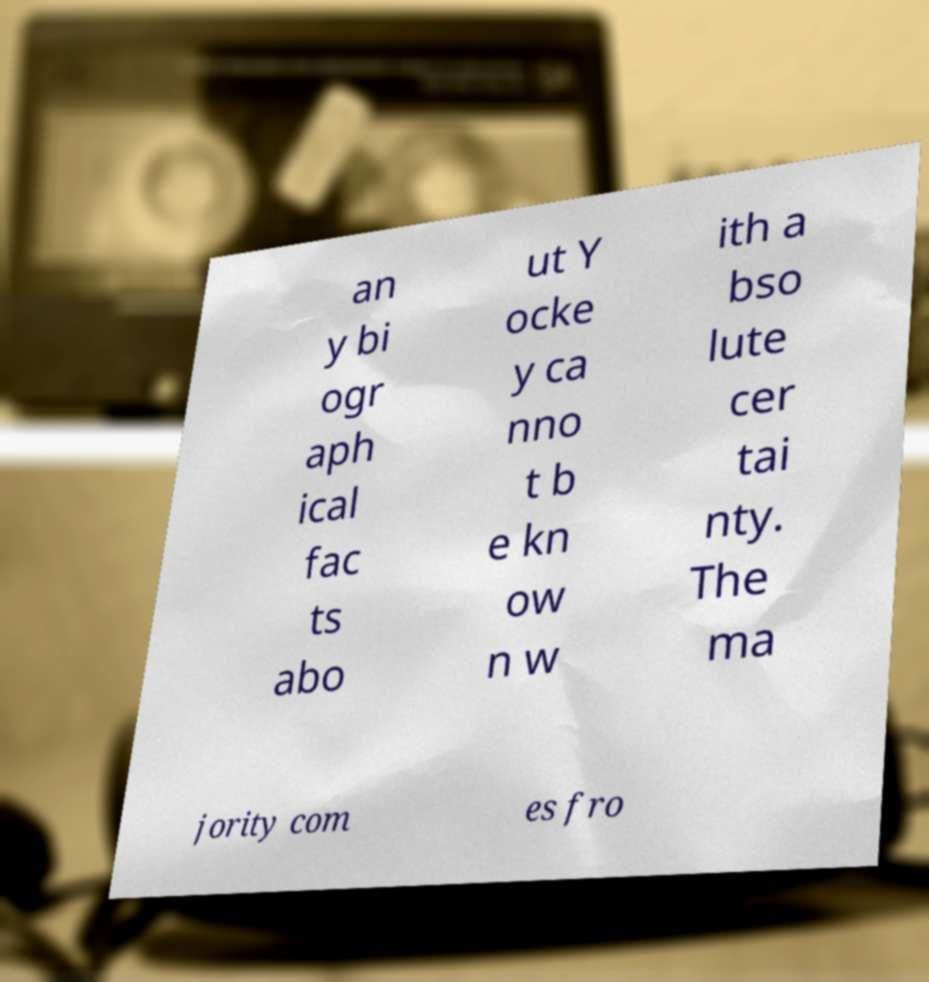What messages or text are displayed in this image? I need them in a readable, typed format. an y bi ogr aph ical fac ts abo ut Y ocke y ca nno t b e kn ow n w ith a bso lute cer tai nty. The ma jority com es fro 